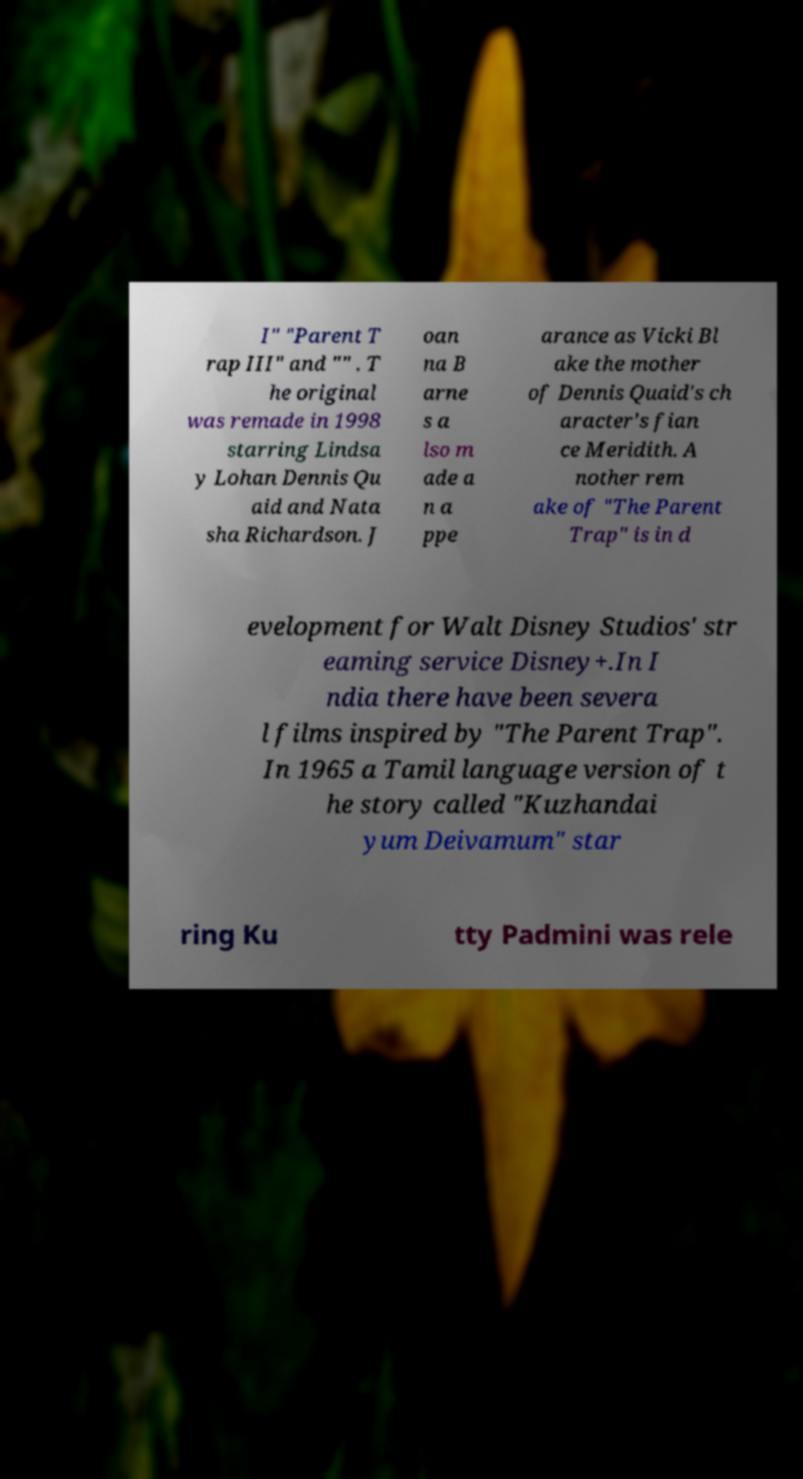What messages or text are displayed in this image? I need them in a readable, typed format. I" "Parent T rap III" and "" . T he original was remade in 1998 starring Lindsa y Lohan Dennis Qu aid and Nata sha Richardson. J oan na B arne s a lso m ade a n a ppe arance as Vicki Bl ake the mother of Dennis Quaid's ch aracter's fian ce Meridith. A nother rem ake of "The Parent Trap" is in d evelopment for Walt Disney Studios' str eaming service Disney+.In I ndia there have been severa l films inspired by "The Parent Trap". In 1965 a Tamil language version of t he story called "Kuzhandai yum Deivamum" star ring Ku tty Padmini was rele 